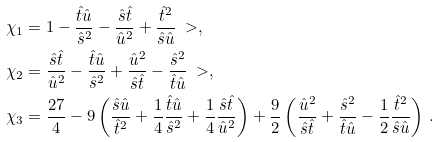<formula> <loc_0><loc_0><loc_500><loc_500>\chi _ { 1 } & = 1 - \frac { \hat { t } \hat { u } } { \hat { s } ^ { 2 } } - \frac { \hat { s } \hat { t } } { \hat { u } ^ { 2 } } + \frac { \hat { t } ^ { 2 } } { \hat { s } \hat { u } } \ > , \\ \chi _ { 2 } & = \frac { \hat { s } \hat { t } } { \hat { u } ^ { 2 } } - \frac { \hat { t } \hat { u } } { \hat { s } ^ { 2 } } + \frac { \hat { u } ^ { 2 } } { \hat { s } \hat { t } } - \frac { \hat { s } ^ { 2 } } { \hat { t } \hat { u } } \ > , \\ \chi _ { 3 } & = \frac { 2 7 } { 4 } - 9 \left ( \frac { \hat { s } \hat { u } } { \hat { t } ^ { 2 } } + \frac { 1 } { 4 } \frac { \hat { t } \hat { u } } { \hat { s } ^ { 2 } } + \frac { 1 } { 4 } \frac { \hat { s } \hat { t } } { \hat { u } ^ { 2 } } \right ) + \frac { 9 } { 2 } \left ( \frac { \hat { u } ^ { 2 } } { \hat { s } \hat { t } } + \frac { \hat { s } ^ { 2 } } { \hat { t } \hat { u } } - \frac { 1 } { 2 } \frac { \hat { t } ^ { 2 } } { \hat { s } \hat { u } } \right ) \, .</formula> 